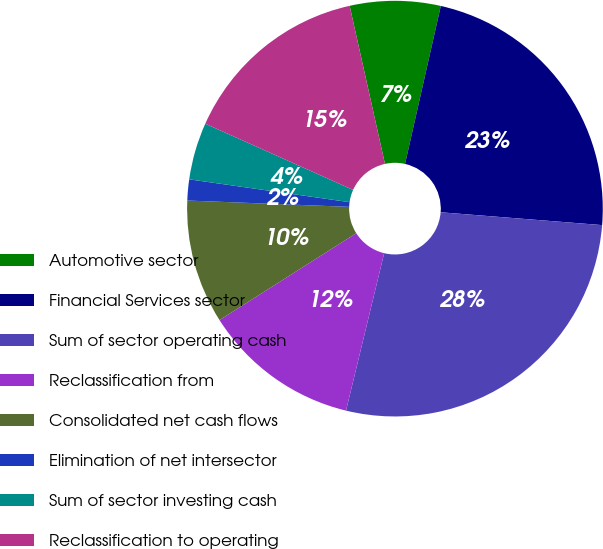<chart> <loc_0><loc_0><loc_500><loc_500><pie_chart><fcel>Automotive sector<fcel>Financial Services sector<fcel>Sum of sector operating cash<fcel>Reclassification from<fcel>Consolidated net cash flows<fcel>Elimination of net intersector<fcel>Sum of sector investing cash<fcel>Reclassification to operating<nl><fcel>7.04%<fcel>22.72%<fcel>27.52%<fcel>12.21%<fcel>9.63%<fcel>1.63%<fcel>4.45%<fcel>14.8%<nl></chart> 